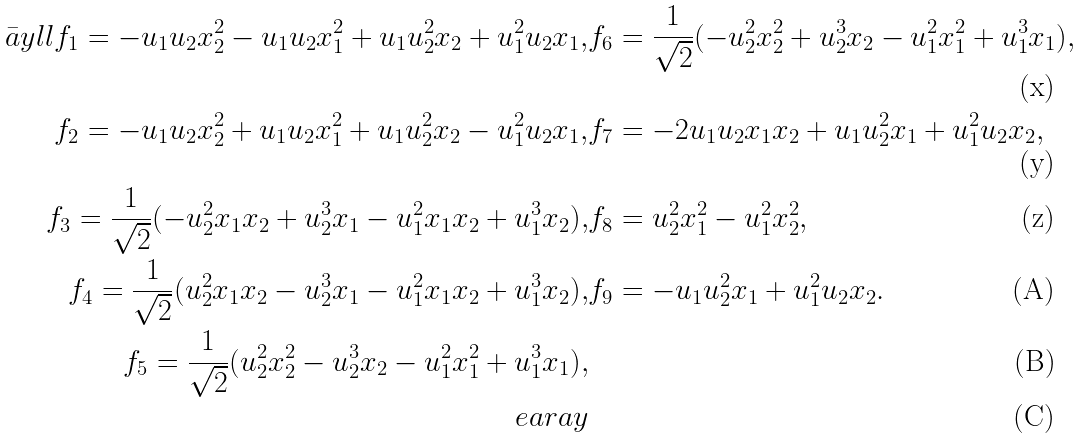<formula> <loc_0><loc_0><loc_500><loc_500>\bar { a } y { l l } f _ { 1 } = - u _ { 1 } u _ { 2 } x _ { 2 } ^ { 2 } - u _ { 1 } u _ { 2 } x _ { 1 } ^ { 2 } + u _ { 1 } u _ { 2 } ^ { 2 } x _ { 2 } + u _ { 1 } ^ { 2 } u _ { 2 } x _ { 1 } , & f _ { 6 } = \frac { 1 } { \sqrt { 2 } } ( - u _ { 2 } ^ { 2 } x _ { 2 } ^ { 2 } + u _ { 2 } ^ { 3 } x _ { 2 } - u _ { 1 } ^ { 2 } x _ { 1 } ^ { 2 } + u _ { 1 } ^ { 3 } x _ { 1 } ) , \\ f _ { 2 } = - u _ { 1 } u _ { 2 } x _ { 2 } ^ { 2 } + u _ { 1 } u _ { 2 } x _ { 1 } ^ { 2 } + u _ { 1 } u _ { 2 } ^ { 2 } x _ { 2 } - u _ { 1 } ^ { 2 } u _ { 2 } x _ { 1 } , & f _ { 7 } = - 2 u _ { 1 } u _ { 2 } x _ { 1 } x _ { 2 } + u _ { 1 } u _ { 2 } ^ { 2 } x _ { 1 } + u _ { 1 } ^ { 2 } u _ { 2 } x _ { 2 } , \\ f _ { 3 } = \frac { 1 } { \sqrt { 2 } } ( - u _ { 2 } ^ { 2 } x _ { 1 } x _ { 2 } + u _ { 2 } ^ { 3 } x _ { 1 } - u _ { 1 } ^ { 2 } x _ { 1 } x _ { 2 } + u _ { 1 } ^ { 3 } x _ { 2 } ) , & f _ { 8 } = u _ { 2 } ^ { 2 } x _ { 1 } ^ { 2 } - u _ { 1 } ^ { 2 } x _ { 2 } ^ { 2 } , \\ f _ { 4 } = \frac { 1 } { \sqrt { 2 } } ( u _ { 2 } ^ { 2 } x _ { 1 } x _ { 2 } - u _ { 2 } ^ { 3 } x _ { 1 } - u _ { 1 } ^ { 2 } x _ { 1 } x _ { 2 } + u _ { 1 } ^ { 3 } x _ { 2 } ) , & f _ { 9 } = - u _ { 1 } u _ { 2 } ^ { 2 } x _ { 1 } + u _ { 1 } ^ { 2 } u _ { 2 } x _ { 2 } . \\ f _ { 5 } = \frac { 1 } { \sqrt { 2 } } ( u _ { 2 } ^ { 2 } x _ { 2 } ^ { 2 } - u _ { 2 } ^ { 3 } x _ { 2 } - u _ { 1 } ^ { 2 } x _ { 1 } ^ { 2 } + u _ { 1 } ^ { 3 } x _ { 1 } ) , \\ \ e a r a y</formula> 